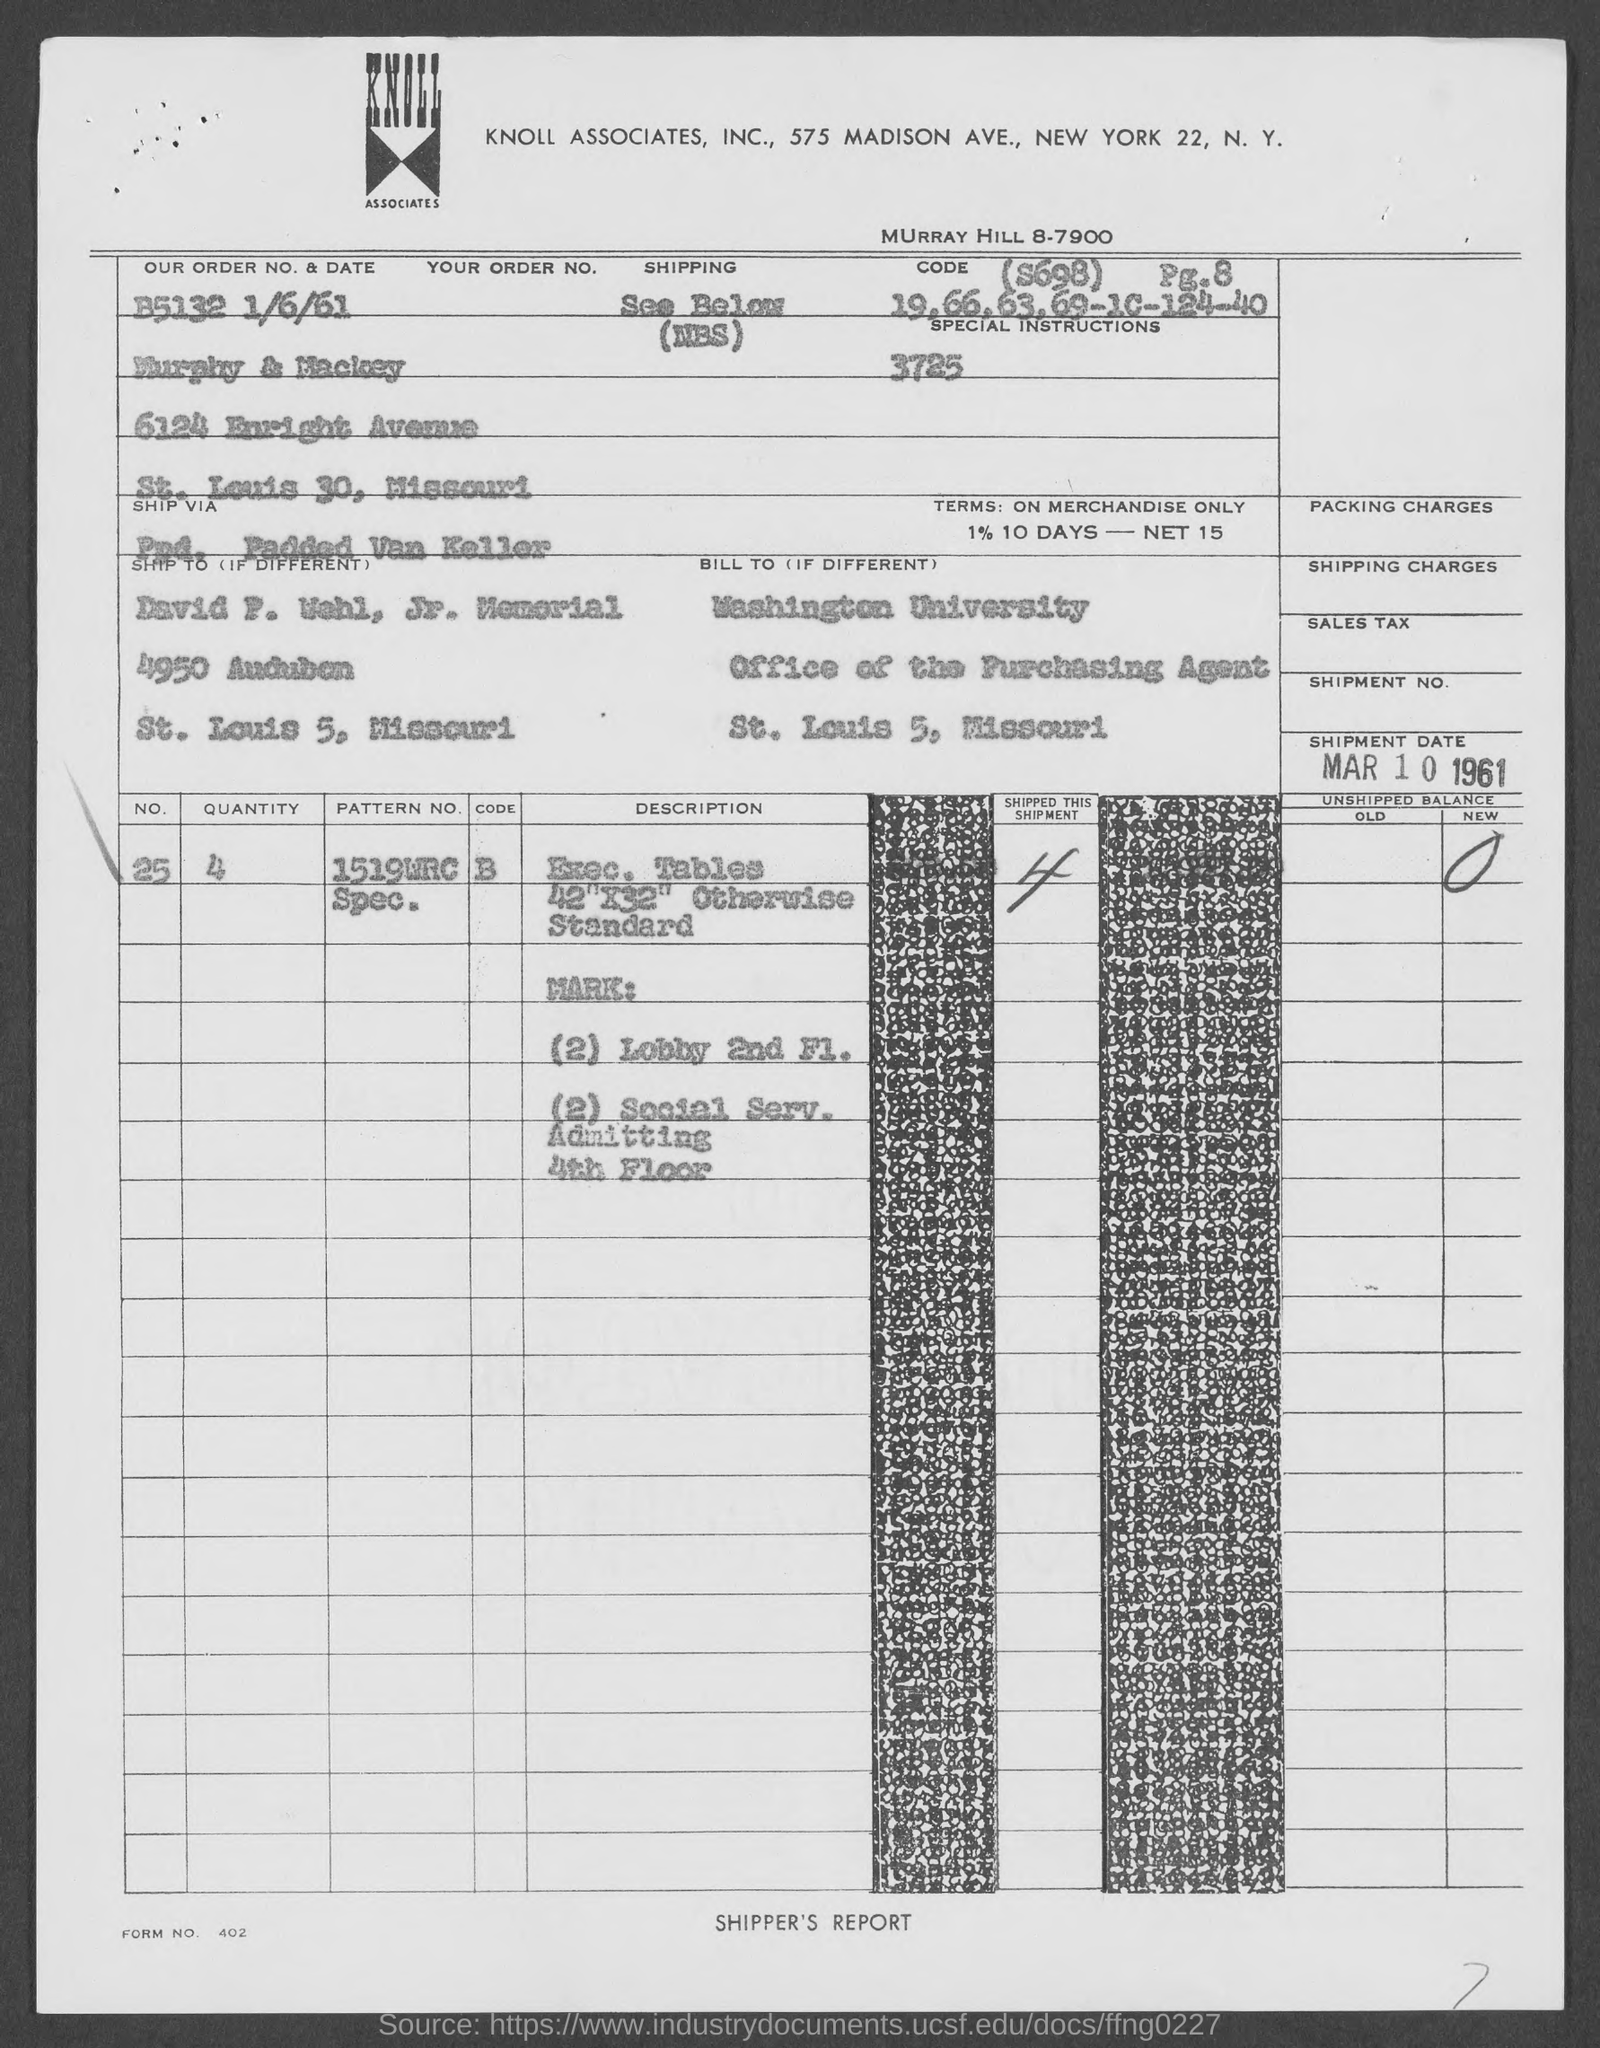Highlight a few significant elements in this photo. Washington University is mentioned in the billing address. The quantity of the item given in the document is 4. The order number is B5132 and the date is 1/6/61, as mentioned in the document. The form number mentioned in the document is 402... The pattern number of the item mentioned in the document is 1519WRC Specification No. XYZ. 